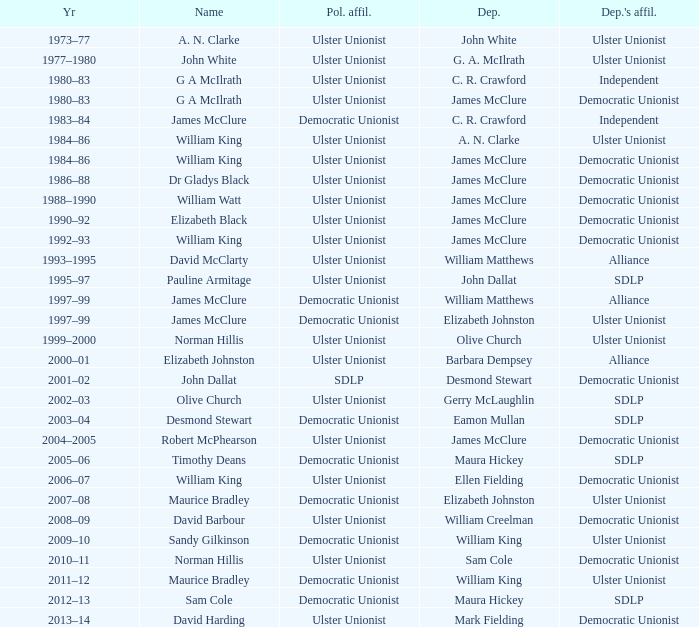What is the name of the deputy in 1992–93? James McClure. 